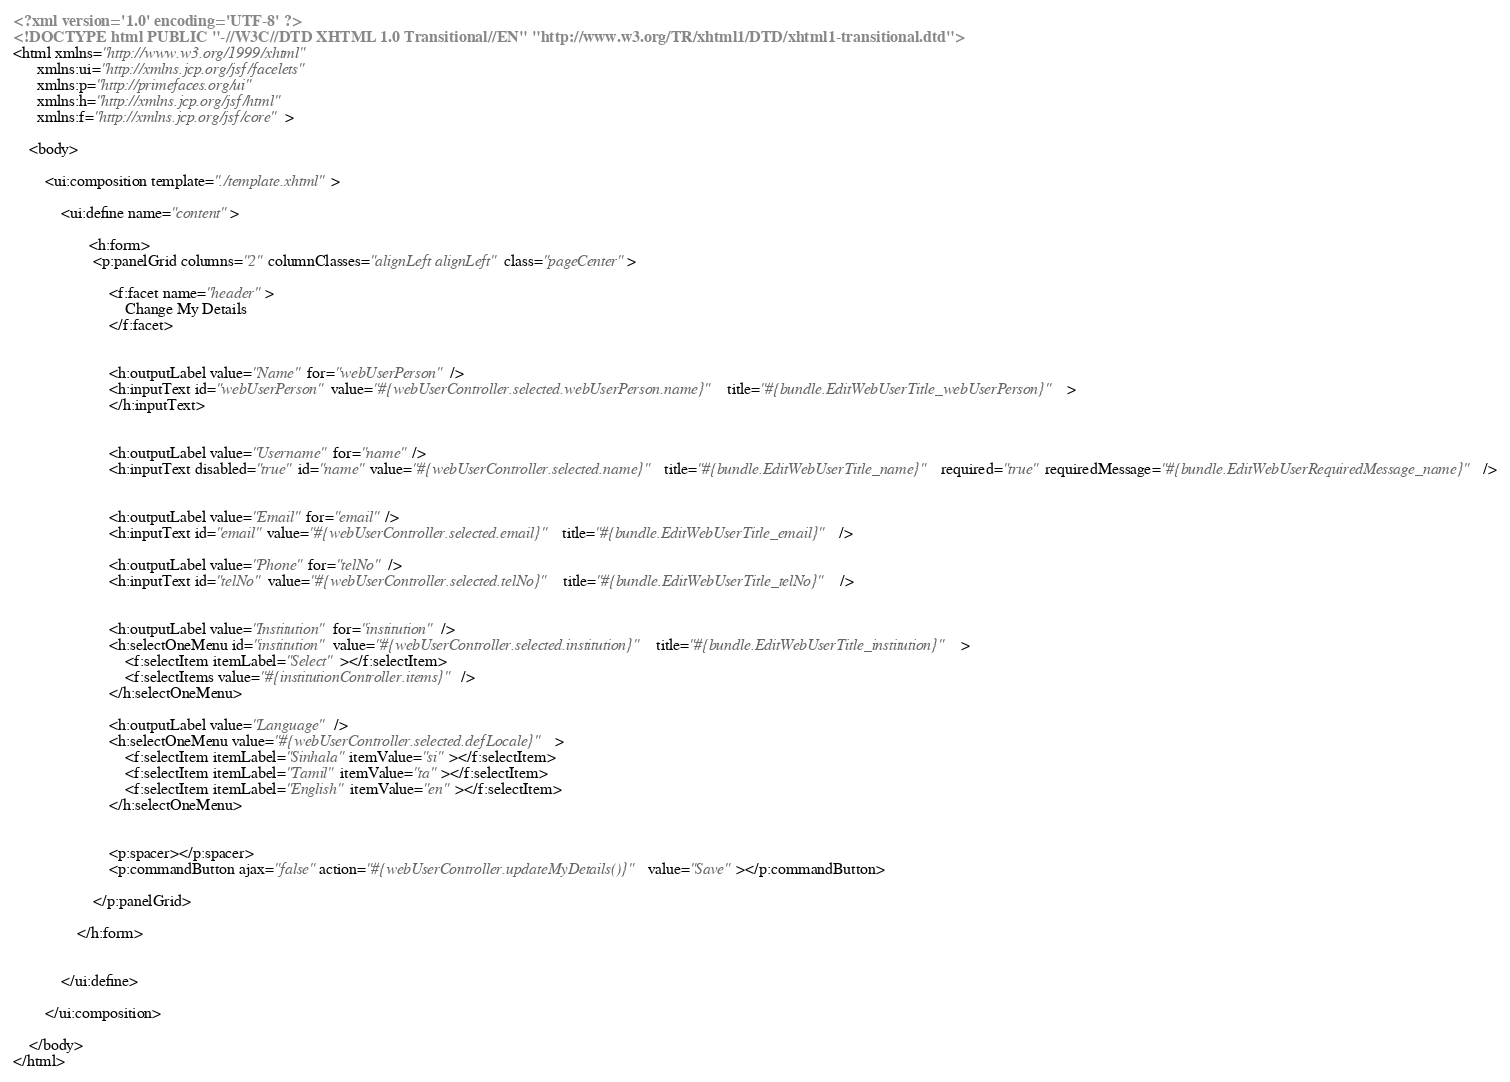Convert code to text. <code><loc_0><loc_0><loc_500><loc_500><_HTML_><?xml version='1.0' encoding='UTF-8' ?>
<!DOCTYPE html PUBLIC "-//W3C//DTD XHTML 1.0 Transitional//EN" "http://www.w3.org/TR/xhtml1/DTD/xhtml1-transitional.dtd">
<html xmlns="http://www.w3.org/1999/xhtml"
      xmlns:ui="http://xmlns.jcp.org/jsf/facelets"
      xmlns:p="http://primefaces.org/ui"
      xmlns:h="http://xmlns.jcp.org/jsf/html"
      xmlns:f="http://xmlns.jcp.org/jsf/core">

    <body>

        <ui:composition template="./template.xhtml">

            <ui:define name="content">
                
                   <h:form>
                    <p:panelGrid columns="2" columnClasses="alignLeft alignLeft" class="pageCenter">

                        <f:facet name="header" >
                            Change My Details
                        </f:facet>


                        <h:outputLabel value="Name" for="webUserPerson" />
                        <h:inputText id="webUserPerson" value="#{webUserController.selected.webUserPerson.name}" title="#{bundle.EditWebUserTitle_webUserPerson}" >
                        </h:inputText>

                        
                        <h:outputLabel value="Username" for="name" />
                        <h:inputText disabled="true" id="name" value="#{webUserController.selected.name}" title="#{bundle.EditWebUserTitle_name}" required="true" requiredMessage="#{bundle.EditWebUserRequiredMessage_name}"/>


                        <h:outputLabel value="Email" for="email" />
                        <h:inputText id="email" value="#{webUserController.selected.email}" title="#{bundle.EditWebUserTitle_email}" />
                        
                        <h:outputLabel value="Phone" for="telNo" />
                        <h:inputText id="telNo" value="#{webUserController.selected.telNo}" title="#{bundle.EditWebUserTitle_telNo}" />


                        <h:outputLabel value="Institution" for="institution" />
                        <h:selectOneMenu id="institution" value="#{webUserController.selected.institution}" title="#{bundle.EditWebUserTitle_institution}" >
                            <f:selectItem itemLabel="Select" ></f:selectItem>
                            <f:selectItems value="#{institutionController.items}"/>
                        </h:selectOneMenu>

                        <h:outputLabel value="Language"  />
                        <h:selectOneMenu value="#{webUserController.selected.defLocale}" >
                            <f:selectItem itemLabel="Sinhala" itemValue="si" ></f:selectItem>
                            <f:selectItem itemLabel="Tamil" itemValue="ta" ></f:selectItem>
                            <f:selectItem itemLabel="English" itemValue="en" ></f:selectItem>
                        </h:selectOneMenu>


                        <p:spacer></p:spacer>
                        <p:commandButton ajax="false" action="#{webUserController.updateMyDetails()}" value="Save" ></p:commandButton>

                    </p:panelGrid>

                </h:form>
                
                
            </ui:define>

        </ui:composition>

    </body>
</html>
</code> 